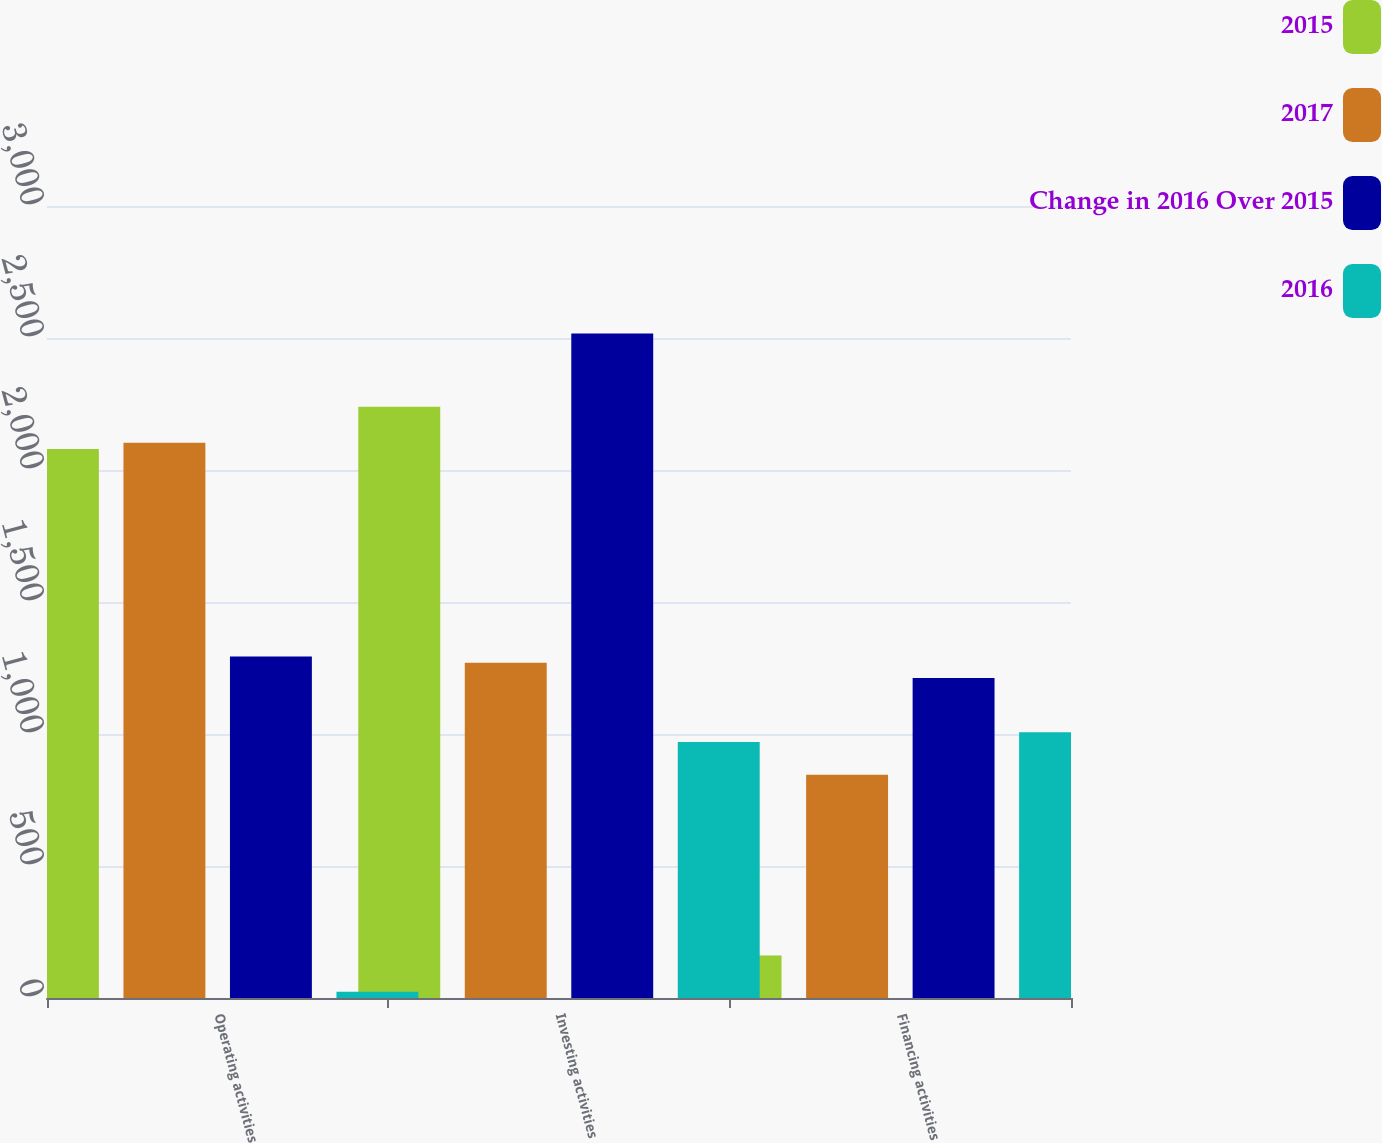Convert chart. <chart><loc_0><loc_0><loc_500><loc_500><stacked_bar_chart><ecel><fcel>Operating activities<fcel>Investing activities<fcel>Financing activities<nl><fcel>2015<fcel>2079.6<fcel>2239.6<fcel>161.4<nl><fcel>2017<fcel>2103.5<fcel>1270.1<fcel>845.7<nl><fcel>Change in 2016 Over 2015<fcel>1293.6<fcel>2517.5<fcel>1211.8<nl><fcel>2016<fcel>23.9<fcel>969.5<fcel>1007.1<nl></chart> 